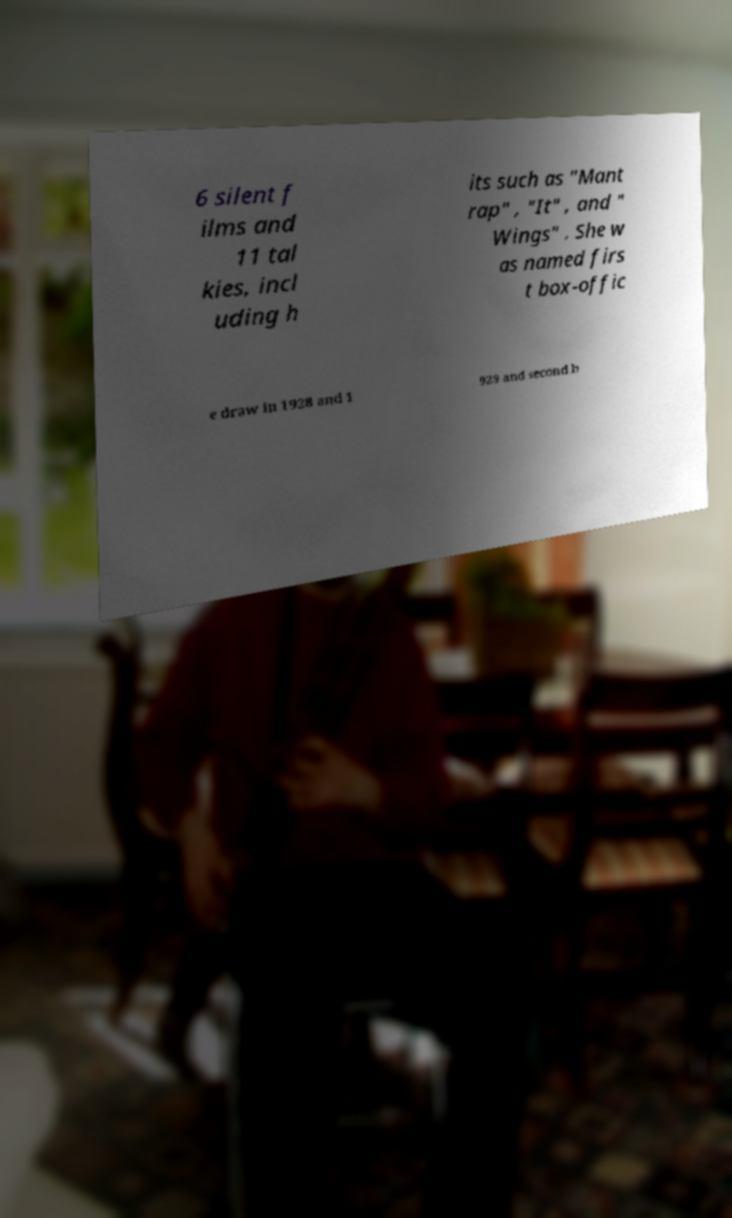Please read and relay the text visible in this image. What does it say? 6 silent f ilms and 11 tal kies, incl uding h its such as "Mant rap" , "It" , and " Wings" . She w as named firs t box-offic e draw in 1928 and 1 929 and second b 